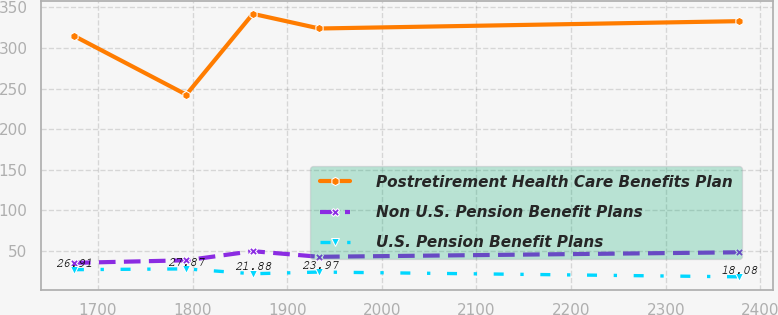Convert chart. <chart><loc_0><loc_0><loc_500><loc_500><line_chart><ecel><fcel>Postretirement Health Care Benefits Plan<fcel>Non U.S. Pension Benefit Plans<fcel>U.S. Pension Benefit Plans<nl><fcel>1674.66<fcel>314.91<fcel>35.28<fcel>26.91<nl><fcel>1793.43<fcel>242.44<fcel>38.45<fcel>27.87<nl><fcel>1863.73<fcel>342<fcel>49.65<fcel>21.88<nl><fcel>1934.03<fcel>323.94<fcel>42.75<fcel>23.97<nl><fcel>2377.67<fcel>332.97<fcel>48.29<fcel>18.08<nl></chart> 